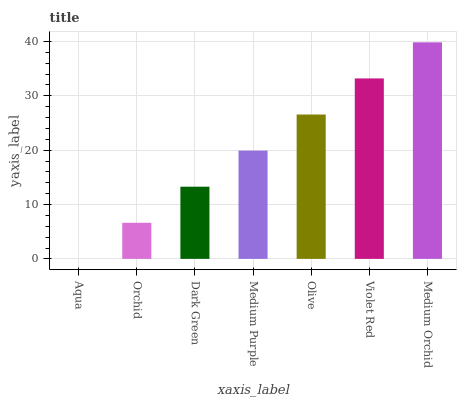Is Orchid the minimum?
Answer yes or no. No. Is Orchid the maximum?
Answer yes or no. No. Is Orchid greater than Aqua?
Answer yes or no. Yes. Is Aqua less than Orchid?
Answer yes or no. Yes. Is Aqua greater than Orchid?
Answer yes or no. No. Is Orchid less than Aqua?
Answer yes or no. No. Is Medium Purple the high median?
Answer yes or no. Yes. Is Medium Purple the low median?
Answer yes or no. Yes. Is Medium Orchid the high median?
Answer yes or no. No. Is Aqua the low median?
Answer yes or no. No. 